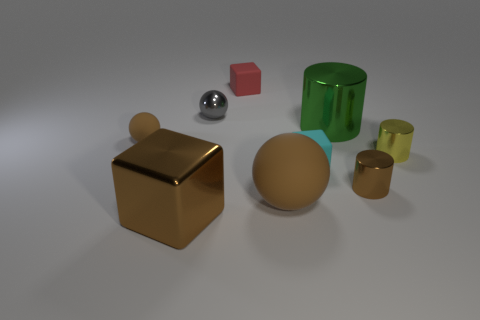There is a small sphere that is the same color as the big metal cube; what is its material?
Ensure brevity in your answer.  Rubber. The large cube that is the same material as the large green object is what color?
Offer a terse response. Brown. What number of metallic objects are right of the tiny red block and in front of the yellow thing?
Offer a terse response. 1. Is the material of the cyan thing the same as the big green cylinder?
Ensure brevity in your answer.  No. There is a matte object that is the same size as the brown metallic block; what is its shape?
Keep it short and to the point. Sphere. There is a small object that is both left of the small red matte block and behind the large cylinder; what is its material?
Your answer should be compact. Metal. How many tiny matte balls are the same color as the large metallic cube?
Provide a succinct answer. 1. How big is the cyan object that is on the right side of the brown ball in front of the tiny cube right of the large brown rubber thing?
Provide a short and direct response. Small. How many metal things are big red cubes or red objects?
Provide a succinct answer. 0. Do the tiny yellow object and the brown thing that is to the right of the big green object have the same shape?
Your answer should be very brief. Yes. 